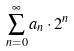<formula> <loc_0><loc_0><loc_500><loc_500>\sum _ { n = 0 } ^ { \infty } a _ { n } \cdot 2 ^ { n }</formula> 